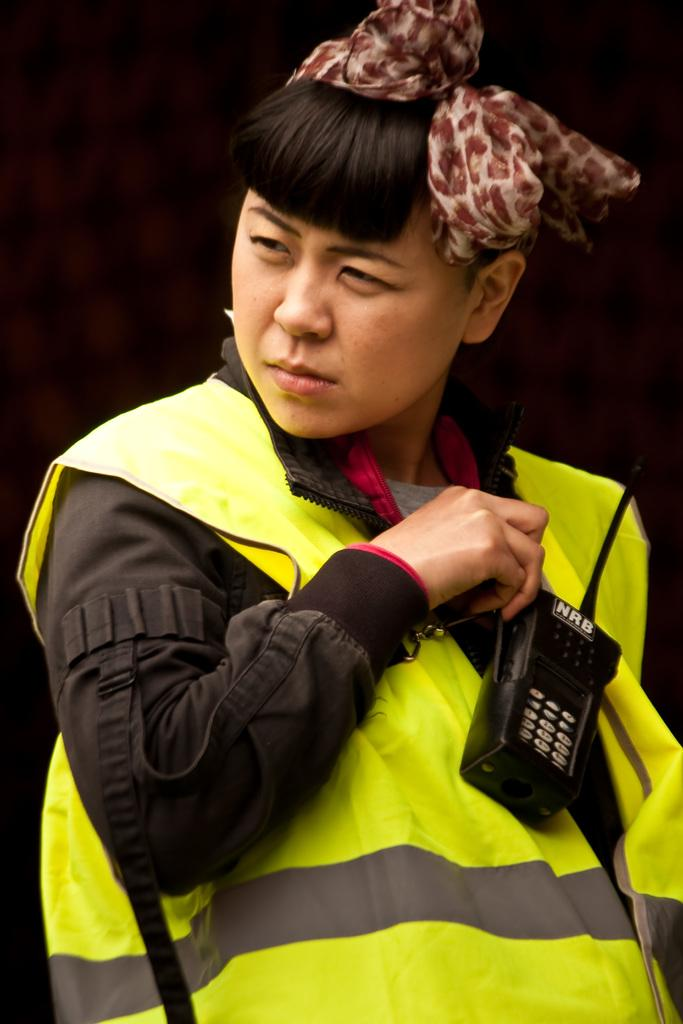Who is the main subject in the image? There is a person in the center of the image. What is the person wearing? The person is wearing a coat and a headband. What is the person holding in the image? The person is holding an object. What can be observed about the background of the image? The background of the image is dark. How many sisters are depicted in the image? There are no sisters present in the image; it features a single person. What type of trade is being conducted in the image? There is no trade being conducted in the image; it shows a person holding an object. 